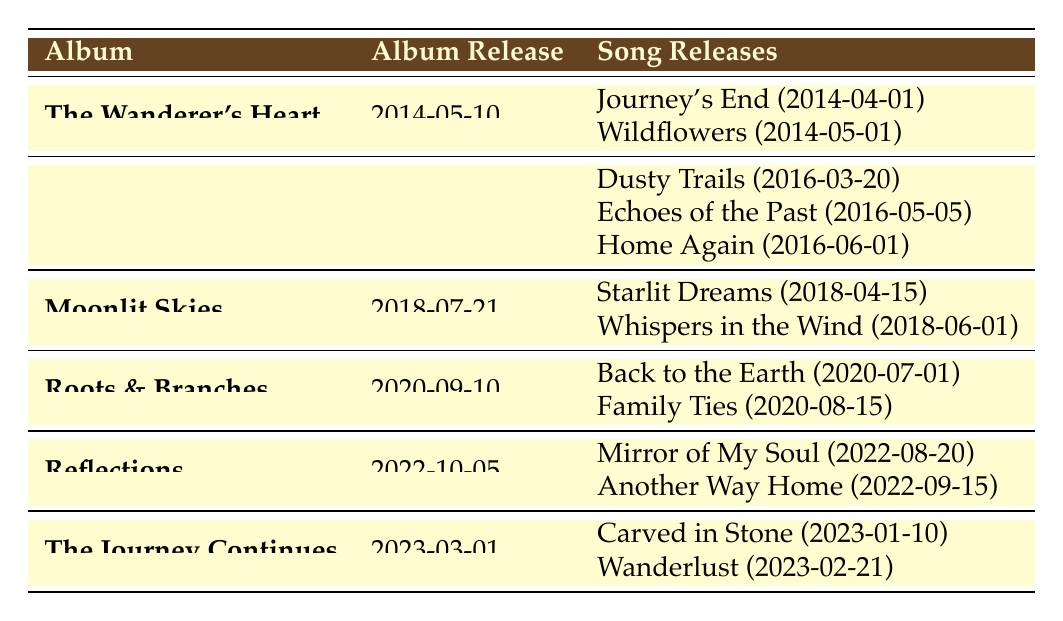What is the release date of the album "Roots & Branches"? The table shows the release date of "Roots & Branches" listed under the Album Release column, which is identified as 2020-09-10.
Answer: 2020-09-10 How many songs were released before the album "Reflections"? From the table, the albums before "Reflections" are "The Wanderer's Heart," "Stories from the Road," "Moonlit Skies," and "Roots & Branches." Counting the songs from these albums gives us a total of 2 (from "The Wanderer's Heart") + 3 (from "Stories from the Road") + 2 (from "Moonlit Skies") + 2 (from "Roots & Branches") = 9 songs.
Answer: 9 True or False: The song "Wanderlust" was released after the album "Roots & Branches." According to the table, "Wanderlust" is listed under the album "The Journey Continues," released on 2023-03-01, which is after "Roots & Branches," released on 2020-09-10. Therefore, the statement is true.
Answer: True Which album had the most song releases? Checking the table, "Stories from the Road" has 3 songs listed, while all other albums have 2 songs each. This indicates that "Stories from the Road" had the most song releases.
Answer: Stories from the Road What is the difference in months between the release date of "Back to the Earth" and "Mirror of My Soul"? "Back to the Earth" was released on 2020-07-01 and "Mirror of My Soul" was released on 2022-08-20. Calculating the difference involves determining the number of full months from July 2020 to August 2022, which is 25 months.
Answer: 25 months 